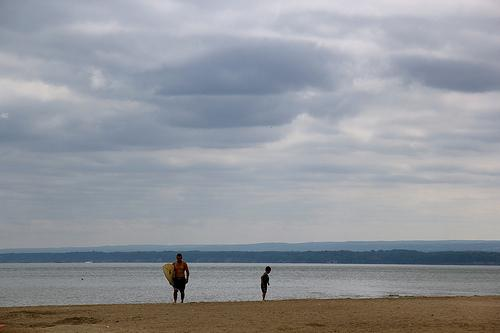What can you observe in the sand, besides the people present in the image? There are multiple tracks in the sand, probably from people walking around. What activity is the man involved in the image, and what is he holding? The man is standing on a beach, holding a yellow surfboard. Briefly describe the weather conditions in the image. Dark storm clouds fill the sky, implying possible bad weather. List two natural elements found in the image's background. Trees on the horizon and hills on the horizon. Describe the atmosphere of the beach scene in the image. A desolate beach scene with calm greenish water, brown sand, two people, stormy weather, hills, and trees on the horizon. What is the uniform the man is wearing in the image? The man is wearing swim shorts, with no shirt on. Please provide a brief description of the location where the subjects are. Two people are standing on a calm beach in front of the water with trees and hills in the background. Identify the relationship between the two main subjects in the image. A man and a young boy are standing on a deserted beach together. Mention two key features of the man's appearance in the picture. The man is wearing dark swim trunks and has a tank top tan. What type of beach is it, based on the sand color, and what condition is the water in? It is a brown sand beach, and the water is calm with a greenish tint. 